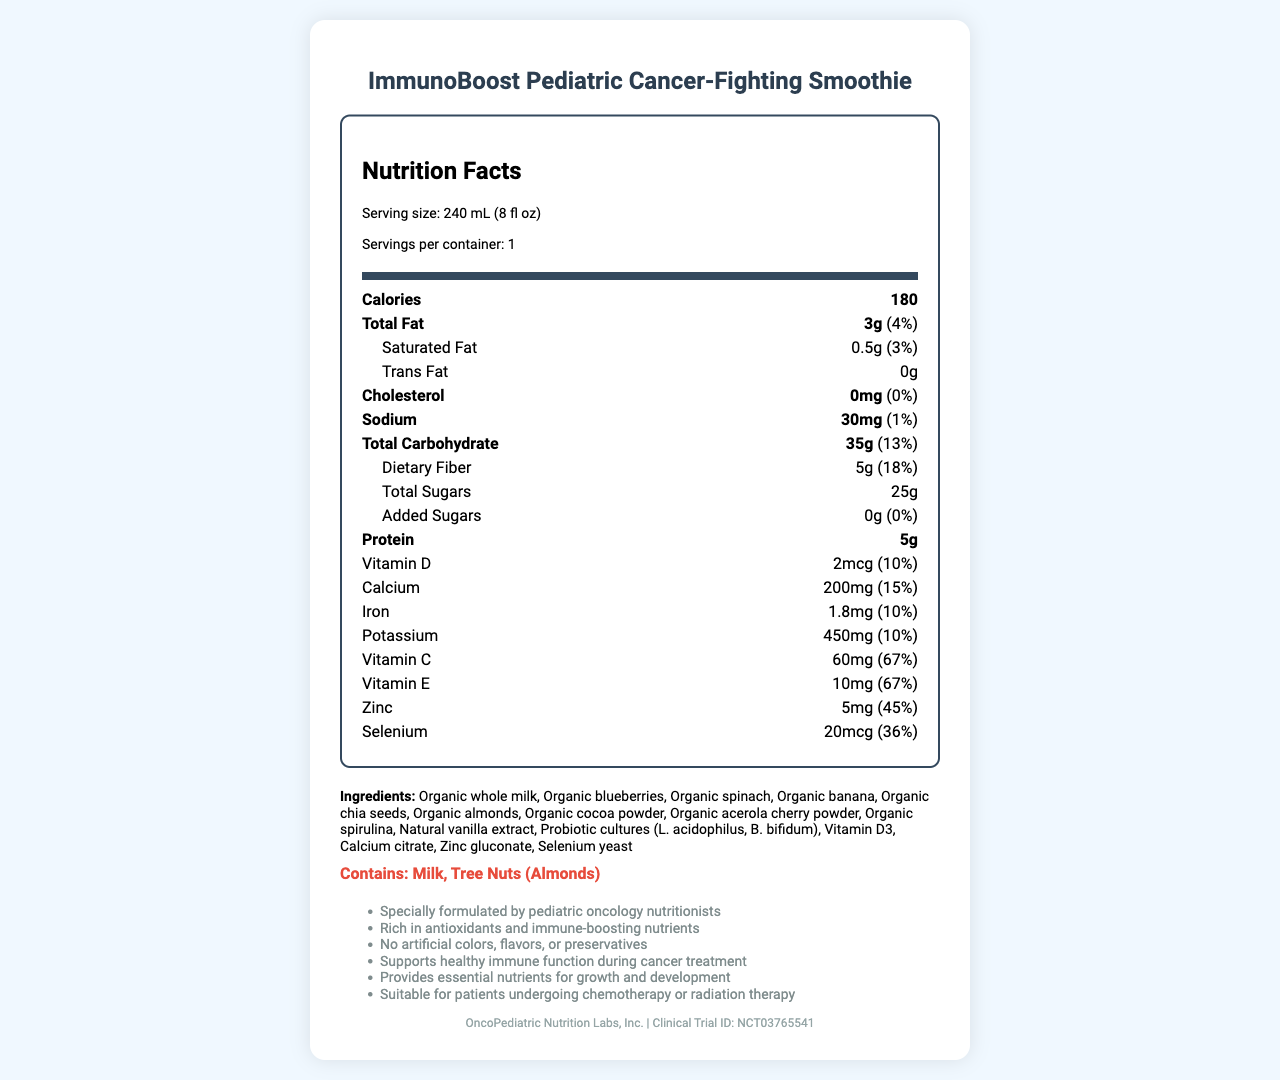what is the serving size of the ImmunoBoost Pediatric Cancer-Fighting Smoothie? The serving size is specified near the top of the Nutrition Facts section.
Answer: 240 mL (8 fl oz) how many grams of dietary fiber are in one serving? Under the Total Carbohydrate section, it is listed as Dietary Fiber 5g.
Answer: 5g what percent of the daily value of vitamin C does this smoothie provide? The amount of Vitamin C and its daily value percentage are provided in the list of vitamins and minerals.
Answer: 67% what is the total amount of sugar, including added sugars, in one serving? The Total Sugars section of the nutrition label lists 25g and the Added Sugars section lists 0g, so the total amount is 25g.
Answer: 25g which ingredients are present in the ImmunoBoost Pediatric Cancer-Fighting Smoothie? The ingredients are listed beneath the nutrient information section.
Answer: Organic whole milk, Organic blueberries, Organic spinach, Organic banana, Organic chia seeds, Organic almonds, Organic cocoa powder, Organic acerola cherry powder, Organic spirulina, Natural vanilla extract, Probiotic cultures (L. acidophilus, B. bifidum), Vitamin D3, Calcium citrate, Zinc gluconate, Selenium yeast what are the primary allergens present in this smoothie? The allergen info section specifically mentions these allergens.
Answer: Milk, Tree Nuts (Almonds) which company manufactures this product? This information is listed at the bottom of the document.
Answer: OncoPediatric Nutrition Labs, Inc. how should this product be stored after opening? This information is provided in the storage instructions section.
Answer: Keep refrigerated. Consume within 24 hours of opening. which of the following nutrients is NOT listed in the nutrition facts? A. Vitamin A B. Vitamin D C. Vitamin C D. Iron Vitamin A is not listed, but Vitamin D, Vitamin C, and Iron are all present.
Answer: A which of these vitamins or minerals contributes the highest percentage of the daily value per serving? I. Vitamin D II. Calcium III. Zinc IV. Vitamin C Vitamin C contributes 67% of the daily value per serving, which is the highest among the options listed.
Answer: IV is this product suitable for patients undergoing chemotherapy or radiation therapy? The additional info section notes that it is suitable for patients undergoing chemotherapy or radiation therapy.
Answer: Yes does the ImmunoBoost Pediatric Cancer-Fighting Smoothie contain any trans fat? The Trans Fat section of the nutrition facts label lists 0g.
Answer: No summarize the main idea of the document. This summary captures the essential details about the product's purpose, nutritional content, and intended use, as provided in the document.
Answer: The ImmunoBoost Pediatric Cancer-Fighting Smoothie is designed for children with cancer and contains immune-boosting ingredients. It provides essential nutrients and is formulated by pediatric oncology nutritionists. It is suitable for children undergoing chemotherapy or radiation therapy. how many clinical trials have been conducted for this product? The document lists a clinical trial ID but does not specify the number of clinical trials conducted.
Answer: Not enough information how many grams of protein does one serving of the smoothie contain? This information is found under the Protein section of the nutrition label.
Answer: 5g 